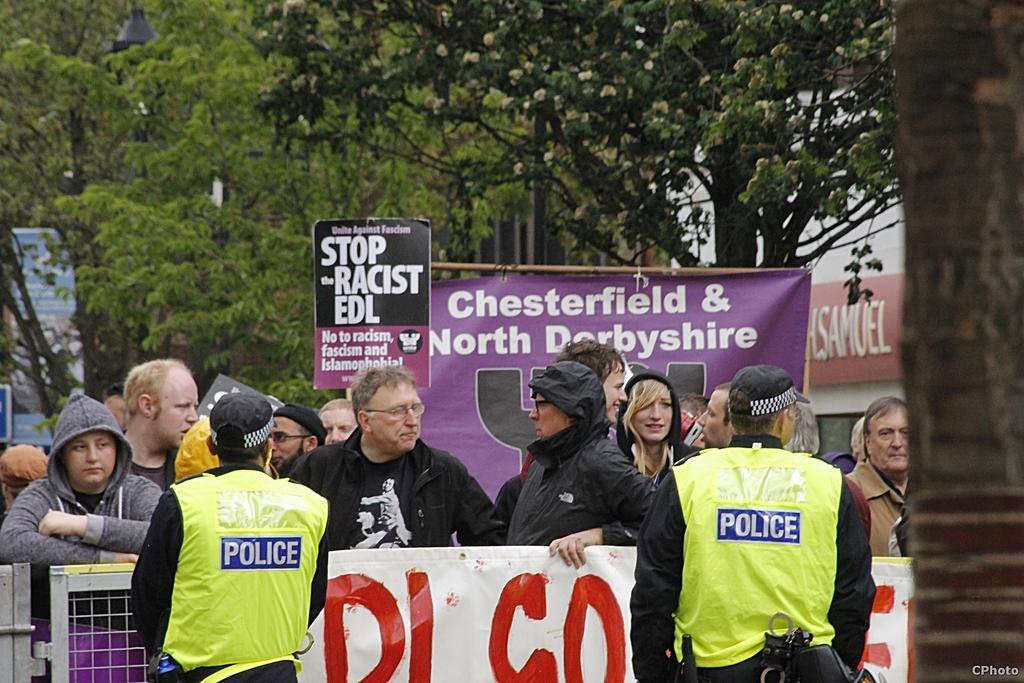Please provide a concise description of this image. On the right it is blurred. In the center of the picture there are group of people, placards, barricades, banner and policemen. In the background there are trees and buildings. 